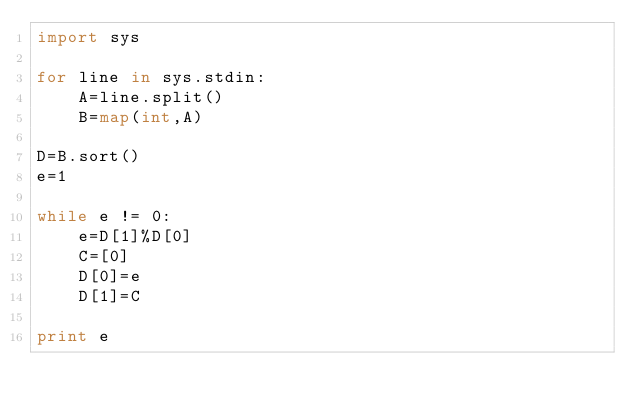<code> <loc_0><loc_0><loc_500><loc_500><_Python_>import sys

for line in sys.stdin:
    A=line.split()
    B=map(int,A)

D=B.sort()
e=1

while e != 0:
    e=D[1]%D[0]
    C=[0]
    D[0]=e
    D[1]=C

print e</code> 